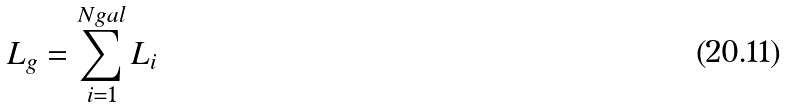Convert formula to latex. <formula><loc_0><loc_0><loc_500><loc_500>L _ { g } = \sum _ { i = 1 } ^ { N g a l } L _ { i }</formula> 